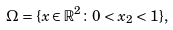Convert formula to latex. <formula><loc_0><loc_0><loc_500><loc_500>\Omega = \{ x \in \mathbb { R } ^ { 2 } \colon 0 < x _ { 2 } < 1 \} ,</formula> 